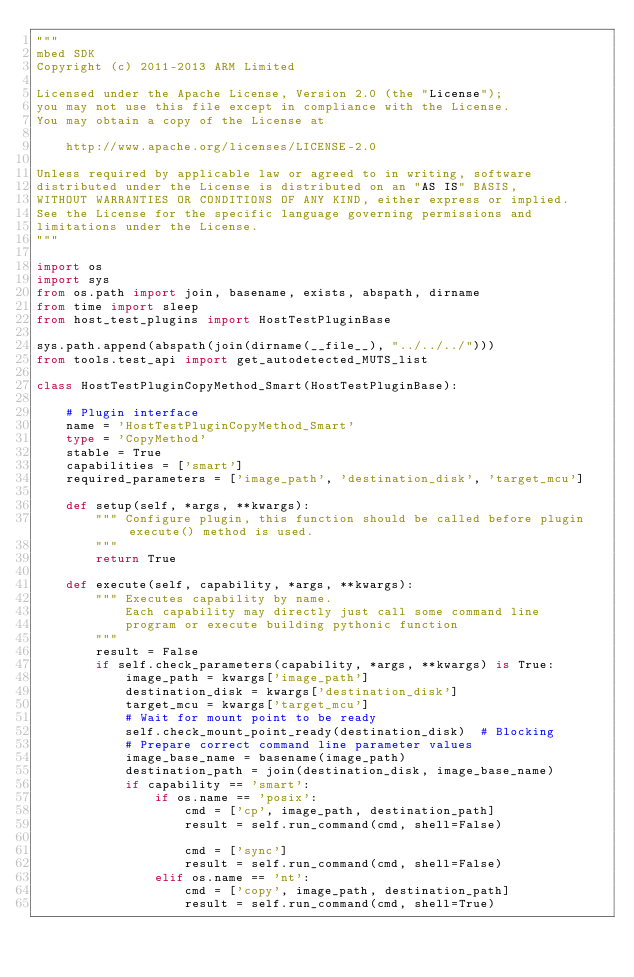<code> <loc_0><loc_0><loc_500><loc_500><_Python_>"""
mbed SDK
Copyright (c) 2011-2013 ARM Limited

Licensed under the Apache License, Version 2.0 (the "License");
you may not use this file except in compliance with the License.
You may obtain a copy of the License at

    http://www.apache.org/licenses/LICENSE-2.0

Unless required by applicable law or agreed to in writing, software
distributed under the License is distributed on an "AS IS" BASIS,
WITHOUT WARRANTIES OR CONDITIONS OF ANY KIND, either express or implied.
See the License for the specific language governing permissions and
limitations under the License.
"""

import os
import sys
from os.path import join, basename, exists, abspath, dirname
from time import sleep
from host_test_plugins import HostTestPluginBase

sys.path.append(abspath(join(dirname(__file__), "../../../")))
from tools.test_api import get_autodetected_MUTS_list

class HostTestPluginCopyMethod_Smart(HostTestPluginBase):

    # Plugin interface
    name = 'HostTestPluginCopyMethod_Smart'
    type = 'CopyMethod'
    stable = True
    capabilities = ['smart']
    required_parameters = ['image_path', 'destination_disk', 'target_mcu']

    def setup(self, *args, **kwargs):
        """ Configure plugin, this function should be called before plugin execute() method is used.
        """
        return True

    def execute(self, capability, *args, **kwargs):
        """ Executes capability by name.
            Each capability may directly just call some command line
            program or execute building pythonic function
        """
        result = False
        if self.check_parameters(capability, *args, **kwargs) is True:
            image_path = kwargs['image_path']
            destination_disk = kwargs['destination_disk']
            target_mcu = kwargs['target_mcu']
            # Wait for mount point to be ready
            self.check_mount_point_ready(destination_disk)  # Blocking
            # Prepare correct command line parameter values
            image_base_name = basename(image_path)
            destination_path = join(destination_disk, image_base_name)
            if capability == 'smart':
                if os.name == 'posix':
                    cmd = ['cp', image_path, destination_path]
                    result = self.run_command(cmd, shell=False)

                    cmd = ['sync']
                    result = self.run_command(cmd, shell=False)
                elif os.name == 'nt':
                    cmd = ['copy', image_path, destination_path]
                    result = self.run_command(cmd, shell=True)
</code> 